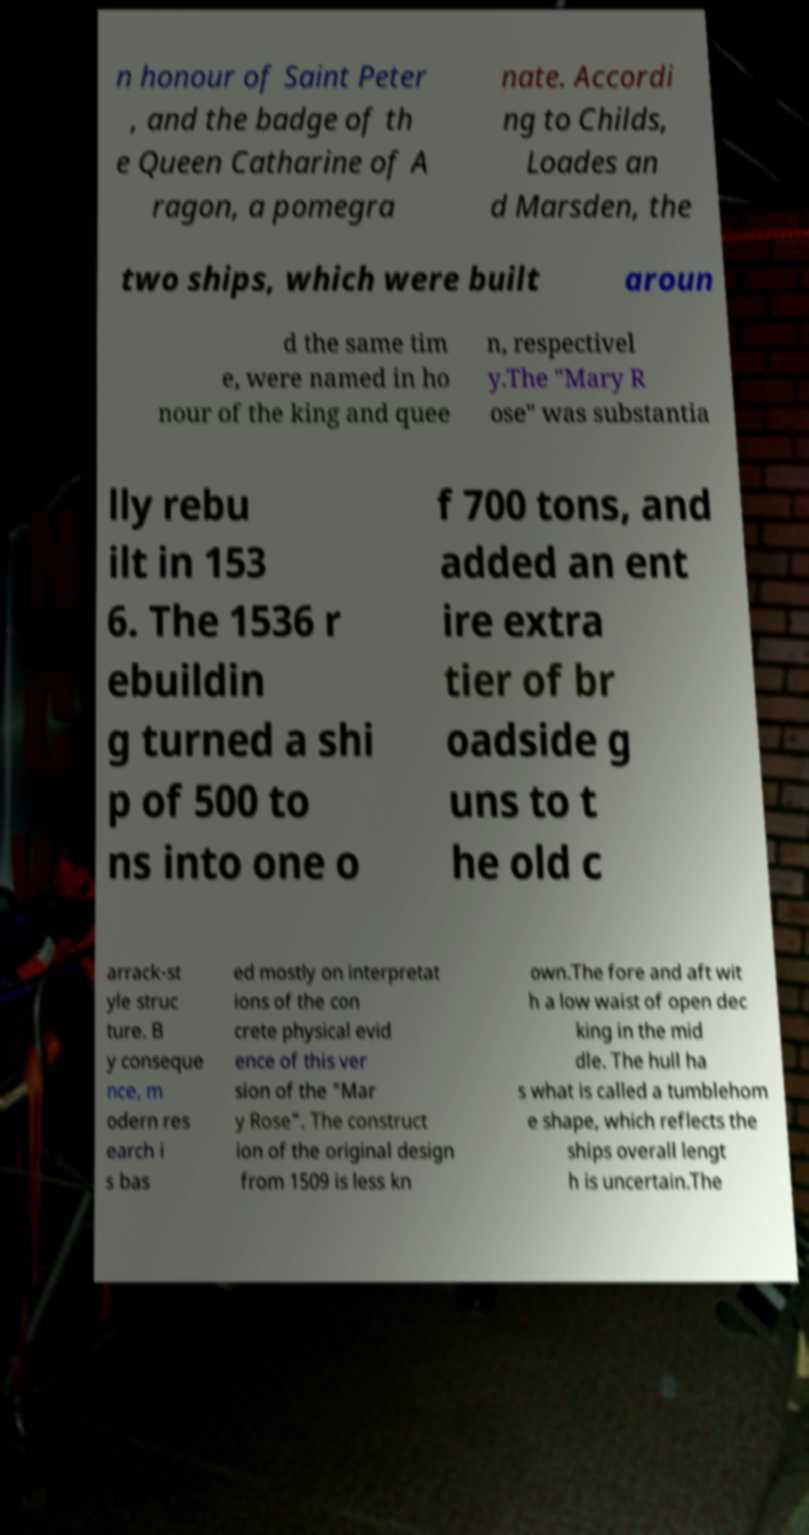Could you extract and type out the text from this image? n honour of Saint Peter , and the badge of th e Queen Catharine of A ragon, a pomegra nate. Accordi ng to Childs, Loades an d Marsden, the two ships, which were built aroun d the same tim e, were named in ho nour of the king and quee n, respectivel y.The "Mary R ose" was substantia lly rebu ilt in 153 6. The 1536 r ebuildin g turned a shi p of 500 to ns into one o f 700 tons, and added an ent ire extra tier of br oadside g uns to t he old c arrack-st yle struc ture. B y conseque nce, m odern res earch i s bas ed mostly on interpretat ions of the con crete physical evid ence of this ver sion of the "Mar y Rose". The construct ion of the original design from 1509 is less kn own.The fore and aft wit h a low waist of open dec king in the mid dle. The hull ha s what is called a tumblehom e shape, which reflects the ships overall lengt h is uncertain.The 